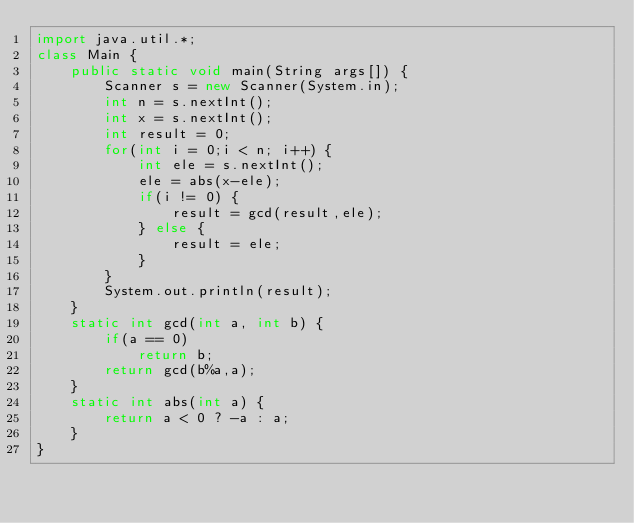Convert code to text. <code><loc_0><loc_0><loc_500><loc_500><_Java_>import java.util.*;
class Main {
    public static void main(String args[]) {
        Scanner s = new Scanner(System.in);
        int n = s.nextInt();
        int x = s.nextInt();
        int result = 0;
        for(int i = 0;i < n; i++) {
            int ele = s.nextInt();
            ele = abs(x-ele);
            if(i != 0) {
                result = gcd(result,ele);
            } else {
                result = ele;
            }
        }
        System.out.println(result);
    }
    static int gcd(int a, int b) {
        if(a == 0)
            return b;
        return gcd(b%a,a);
    }
    static int abs(int a) {
        return a < 0 ? -a : a;
    }
}
</code> 